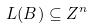<formula> <loc_0><loc_0><loc_500><loc_500>L ( B ) \subseteq Z ^ { n }</formula> 